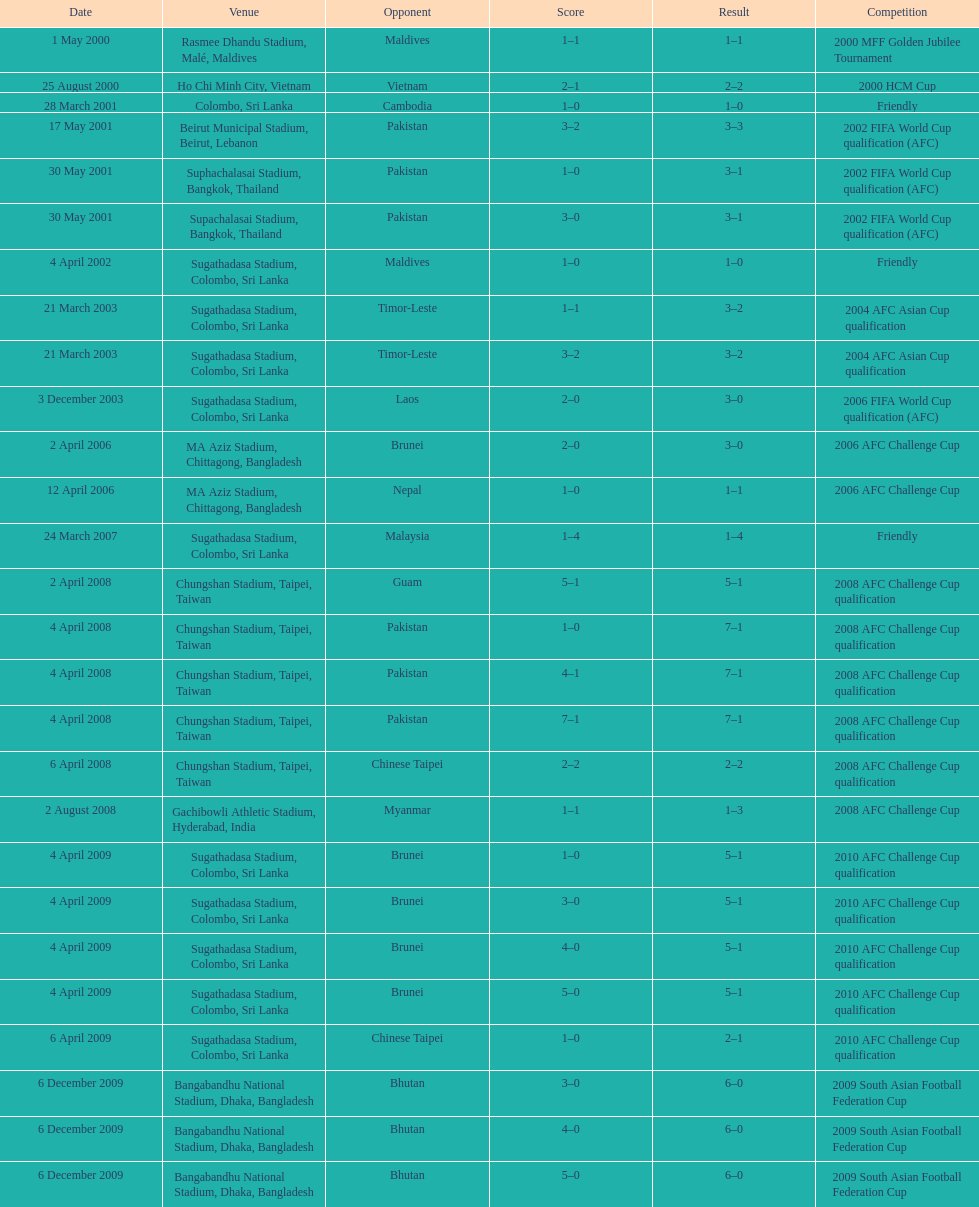What was the total number of goals score in the sri lanka - malaysia game of march 24, 2007? 5. 